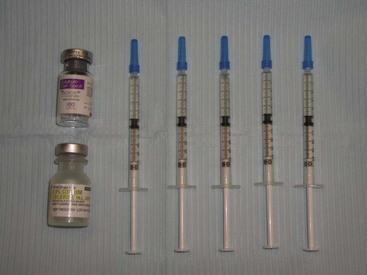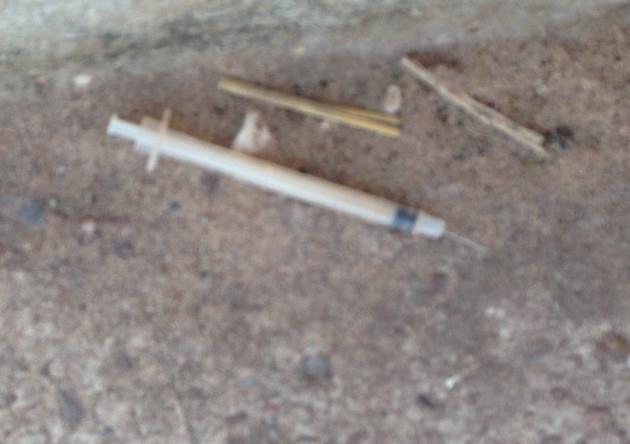The first image is the image on the left, the second image is the image on the right. Assess this claim about the two images: "Each image shows one syringe, which is on a cement-type surface.". Correct or not? Answer yes or no. No. The first image is the image on the left, the second image is the image on the right. Evaluate the accuracy of this statement regarding the images: "There are two syringes lying on the floor". Is it true? Answer yes or no. No. 